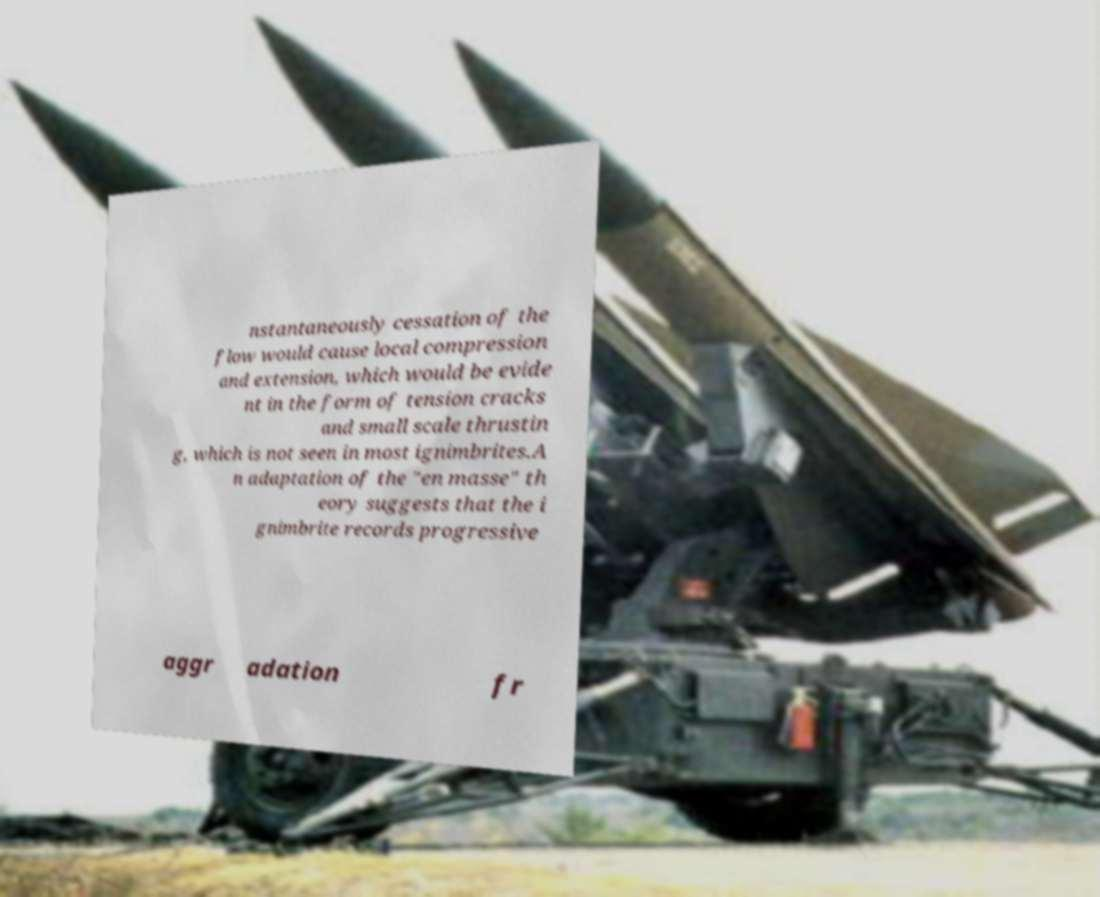There's text embedded in this image that I need extracted. Can you transcribe it verbatim? nstantaneously cessation of the flow would cause local compression and extension, which would be evide nt in the form of tension cracks and small scale thrustin g, which is not seen in most ignimbrites.A n adaptation of the "en masse" th eory suggests that the i gnimbrite records progressive aggr adation fr 